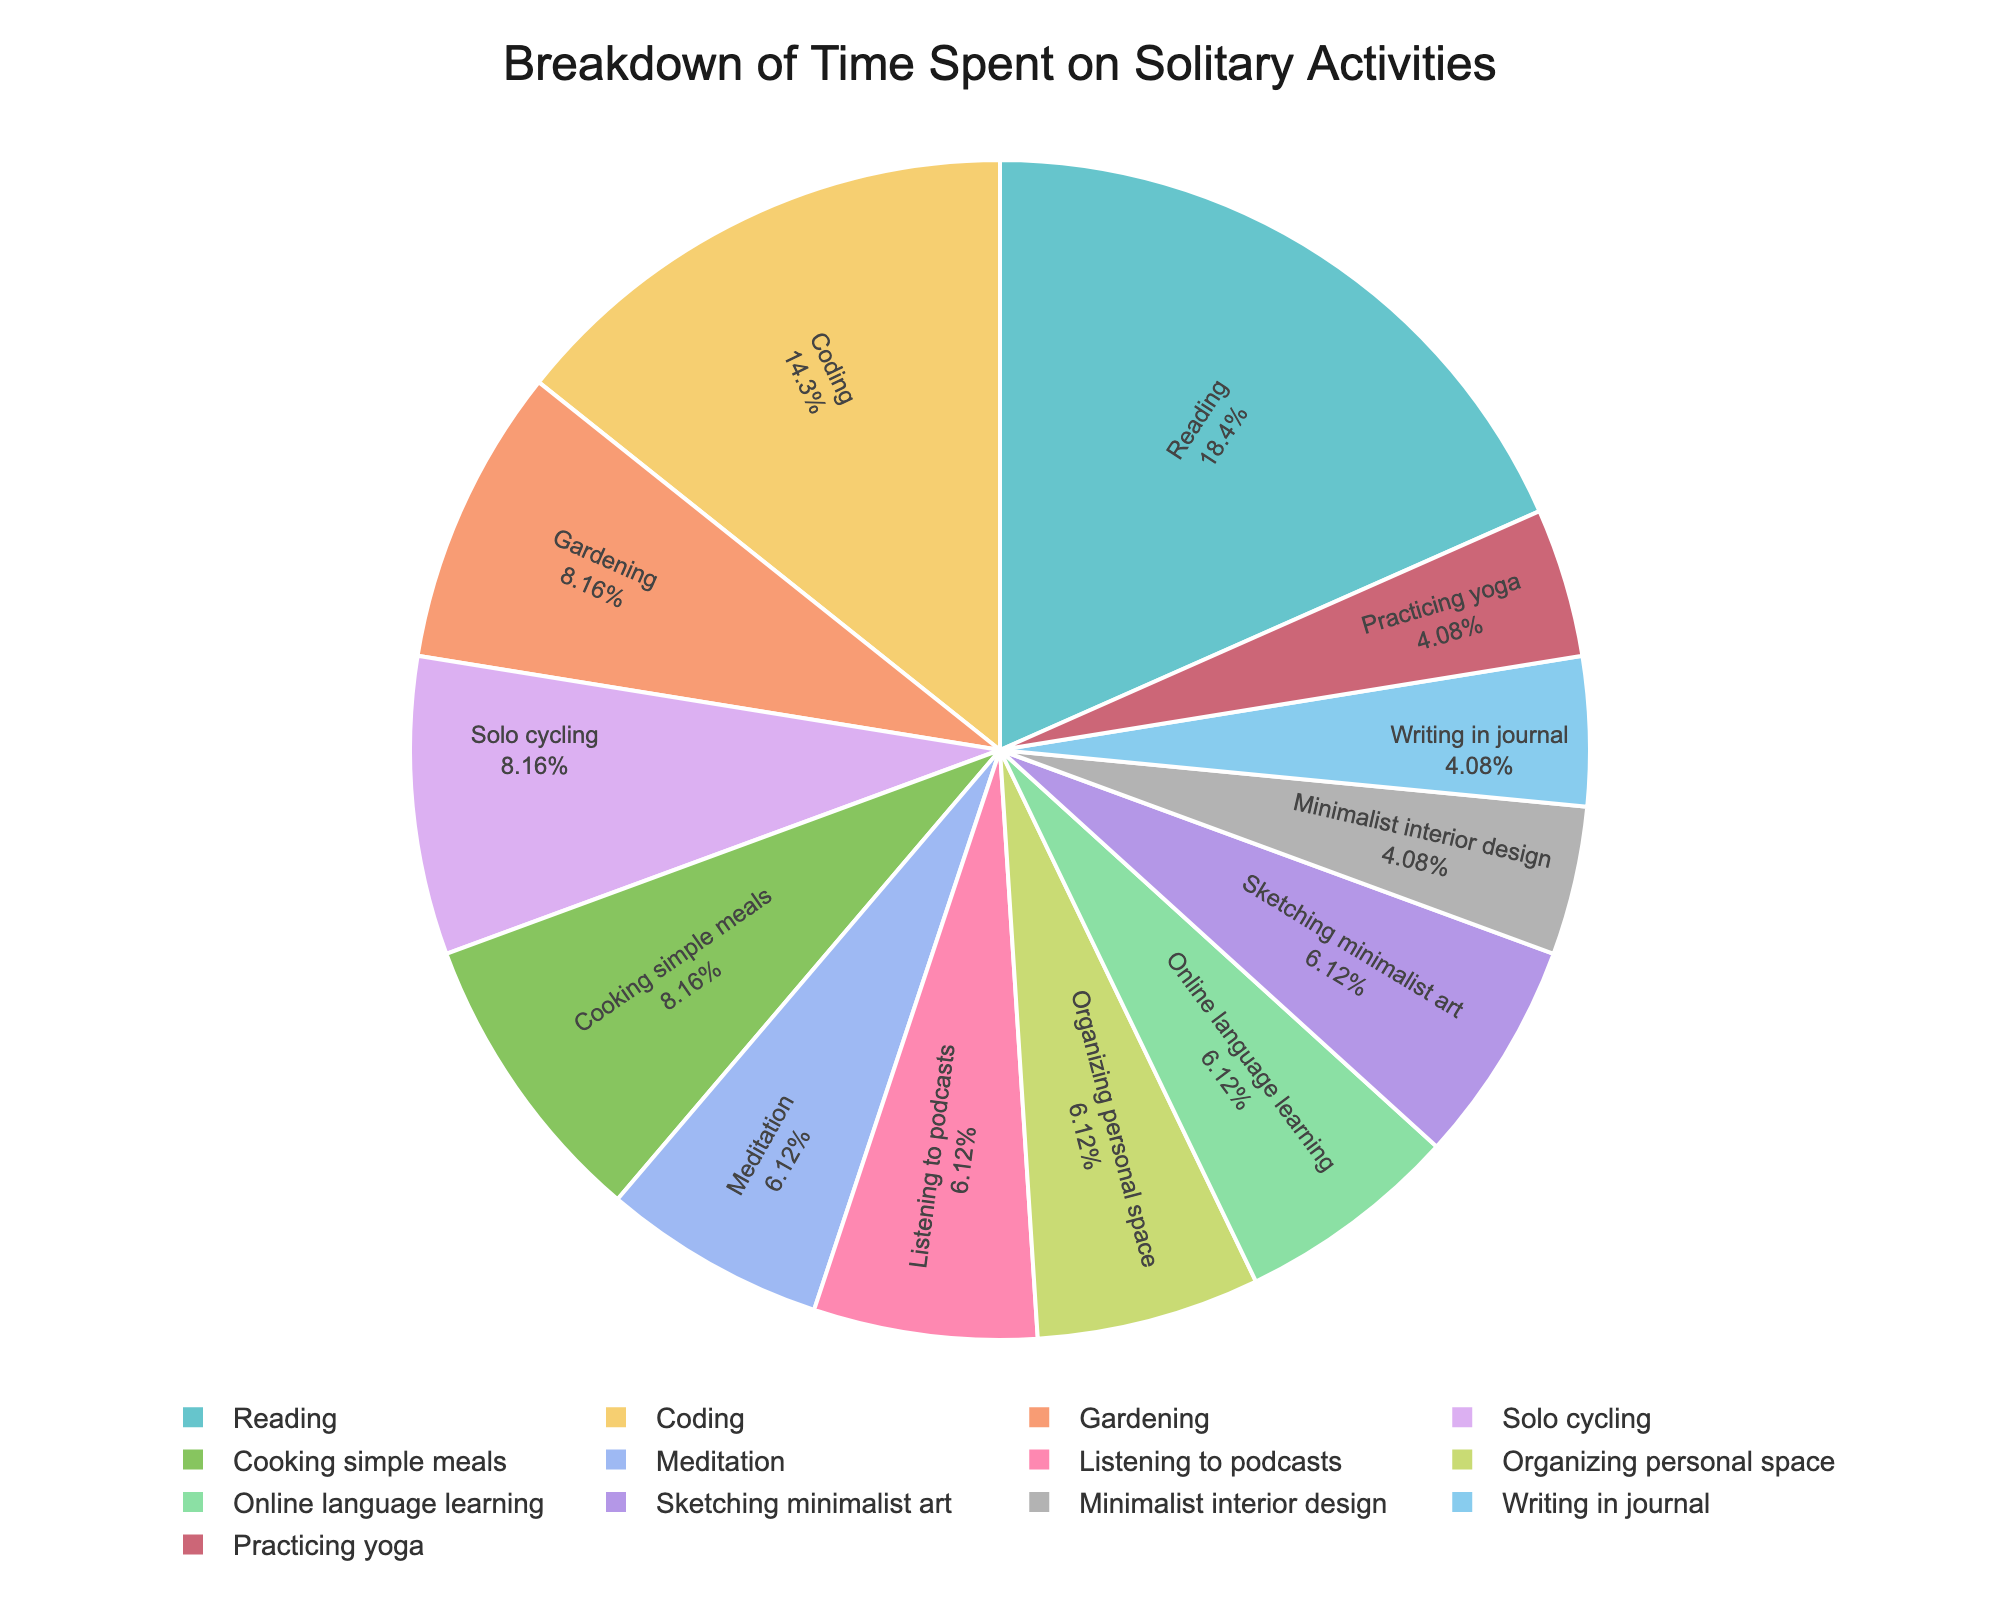How many hours does the Dutch introvert spend on physical activities? Physical activities include gardening, solo cycling, practicing yoga, and cooking simple meals. Summing up the hours: 2 (gardening) + 2 (solo cycling) + 1 (practicing yoga) + 2 (cooking simple meals) = 7
Answer: 7 Which activity takes the most time? By looking at the pie chart, the activity with the largest segment corresponds to reading.
Answer: Reading What percentage of time is spent on creative activities? Creative activities include sketching minimalist art and writing in a journal. Summing the hours gives 1.5 (sketching minimalist art) + 1 (writing in a journal) = 2.5. To find the percentage, use the total hours = 4.5 + 1.5 + 2 + 3.5 + 1 + 2 + 1.5 + 1.5 + 1 + 1 + 1.5 + 2 + 1.5 = 24. Dividing 2.5 by 24 and multiplying by 100 gives (2.5 / 24) * 100 ≈ 10.42
Answer: 10.42 Is more time spent on coding or gardening? Comparing the hours spent, coding takes 3.5 hours while gardening takes 2 hours. Coding is greater.
Answer: Coding How many hours are dedicated to relaxation activities? Relaxation activities include meditation and listening to podcasts. Summing up the hours: 1.5 (meditation) + 1.5 (listening to podcasts) = 3
Answer: 3 Which activities take up equal time? By examining the chart, activities with equal time are meditation (1.5), listening to podcasts (1.5), organizing personal space (1.5), sketching minimalist art (1.5), online language learning (1.5), and writing in a journal (1) and practicing yoga (1).
Answer: Meditation, Listening to podcasts, Organizing personal space, Sketching minimalist art, Online language learning, Writing in a journal, Practicing yoga What is the total time spent on mental and intellectual activities? Mental and intellectual activities include reading, meditation, coding, listening to podcasts, online language learning, and writing in a journal. Summing these: 4.5 (reading) + 1.5 (meditation) + 3.5 (coding) + 1.5 (listening to podcasts) + 1.5 (online language learning) + 1 (writing in a journal) = 13.5
Answer: 13.5 